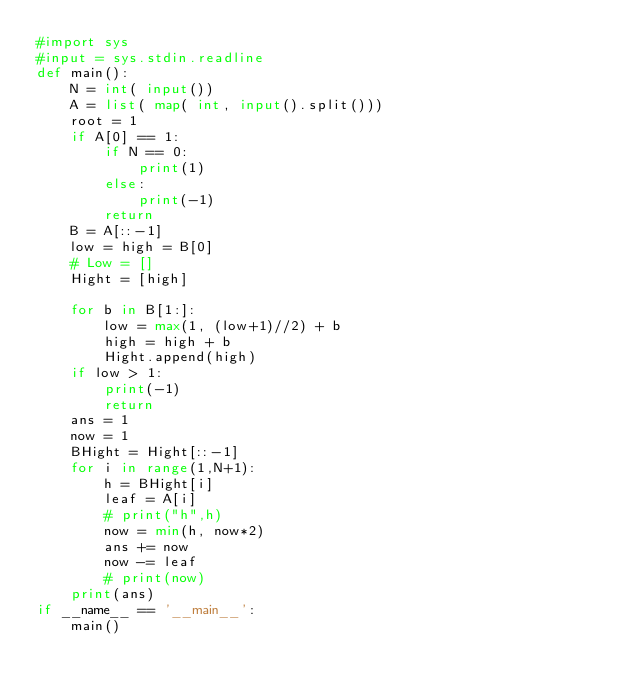<code> <loc_0><loc_0><loc_500><loc_500><_Python_>#import sys
#input = sys.stdin.readline
def main():
    N = int( input())
    A = list( map( int, input().split()))
    root = 1
    if A[0] == 1:
        if N == 0:
            print(1)
        else:
            print(-1)
        return
    B = A[::-1]
    low = high = B[0]
    # Low = []
    Hight = [high]
    
    for b in B[1:]:
        low = max(1, (low+1)//2) + b
        high = high + b
        Hight.append(high)
    if low > 1:
        print(-1)
        return
    ans = 1
    now = 1
    BHight = Hight[::-1]
    for i in range(1,N+1):
        h = BHight[i]
        leaf = A[i]
        # print("h",h)
        now = min(h, now*2)
        ans += now
        now -= leaf
        # print(now)
    print(ans)
if __name__ == '__main__':
    main()
</code> 